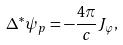Convert formula to latex. <formula><loc_0><loc_0><loc_500><loc_500>\Delta ^ { \ast } \psi _ { p } = - \frac { 4 \pi } { c } J _ { \varphi } ,</formula> 